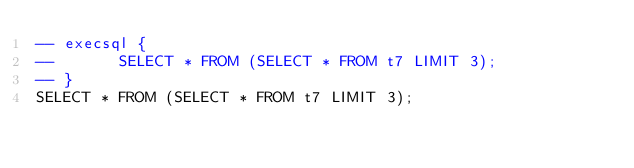Convert code to text. <code><loc_0><loc_0><loc_500><loc_500><_SQL_>-- execsql {
--       SELECT * FROM (SELECT * FROM t7 LIMIT 3);
-- }
SELECT * FROM (SELECT * FROM t7 LIMIT 3);</code> 